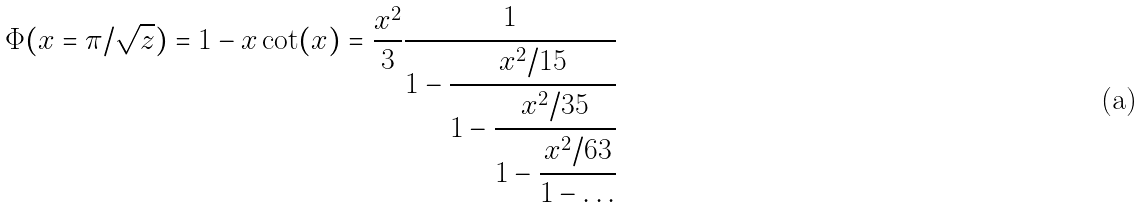Convert formula to latex. <formula><loc_0><loc_0><loc_500><loc_500>\Phi ( x = \pi / \sqrt { z } ) = 1 - x \cot ( x ) = \frac { x ^ { 2 } } { 3 } \cfrac { 1 } { 1 - \cfrac { x ^ { 2 } / 1 5 } { 1 - \cfrac { x ^ { 2 } / 3 5 } { 1 - \cfrac { x ^ { 2 } / 6 3 } { 1 - \dots } } } }</formula> 